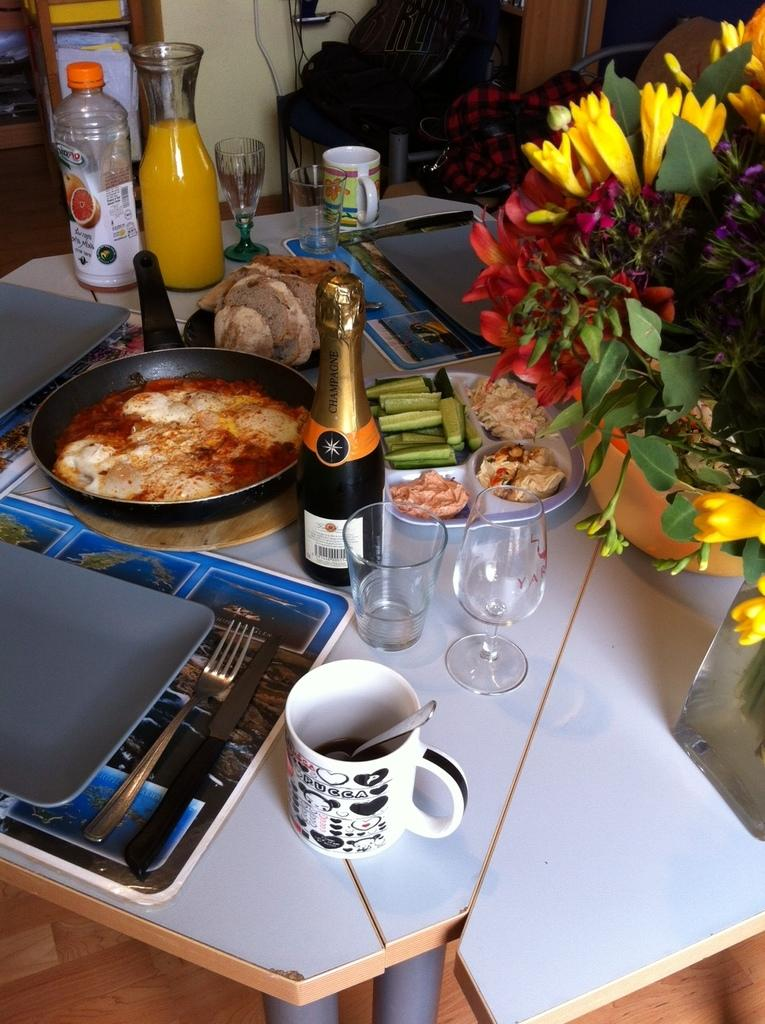What type of furniture is present in the image? There is a table in the image. What can be found on the table? There are food items, glasses, bottles, and a pan on the table. Are there any decorative elements in the image? Yes, there are flowers and a small plant in the image. What type of bun is being used to hold the wool in the image? There is no bun or wool present in the image. What time of day is depicted in the image? The provided facts do not mention the time of day, so it cannot be determined from the image. 